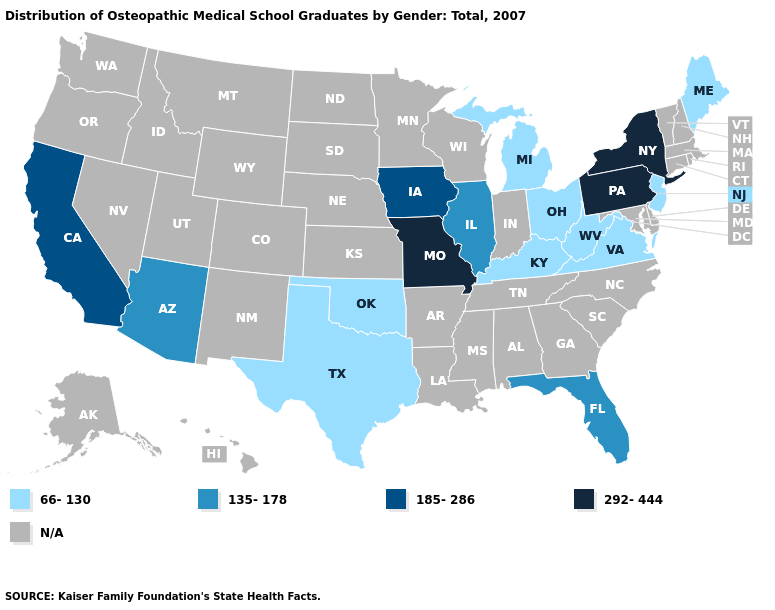What is the value of Hawaii?
Short answer required. N/A. What is the highest value in the MidWest ?
Write a very short answer. 292-444. Is the legend a continuous bar?
Quick response, please. No. Does Arizona have the highest value in the West?
Concise answer only. No. What is the value of West Virginia?
Quick response, please. 66-130. What is the value of Utah?
Write a very short answer. N/A. What is the highest value in the USA?
Concise answer only. 292-444. Does the first symbol in the legend represent the smallest category?
Short answer required. Yes. Name the states that have a value in the range 185-286?
Keep it brief. California, Iowa. Name the states that have a value in the range 292-444?
Give a very brief answer. Missouri, New York, Pennsylvania. 